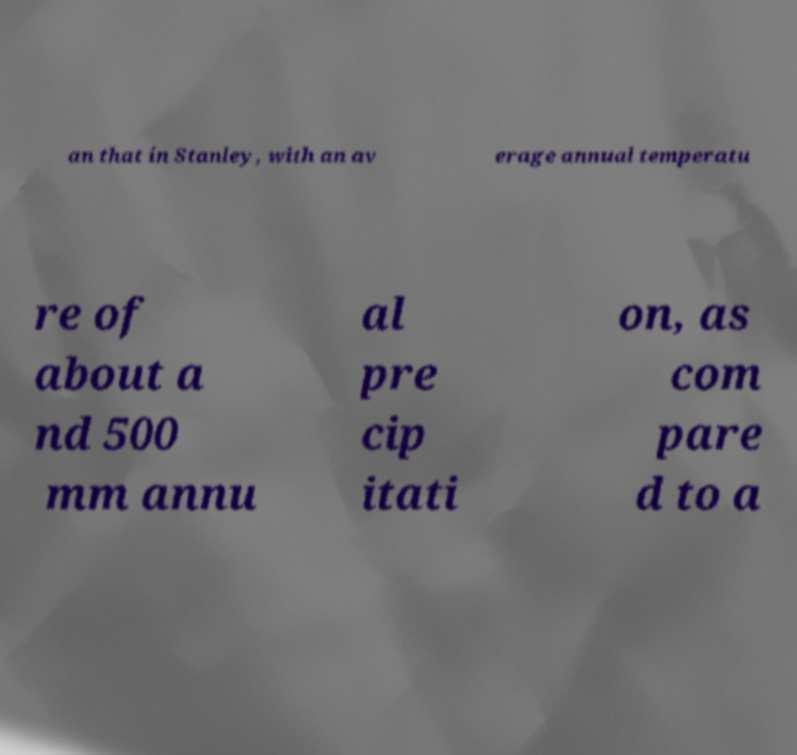I need the written content from this picture converted into text. Can you do that? an that in Stanley, with an av erage annual temperatu re of about a nd 500 mm annu al pre cip itati on, as com pare d to a 